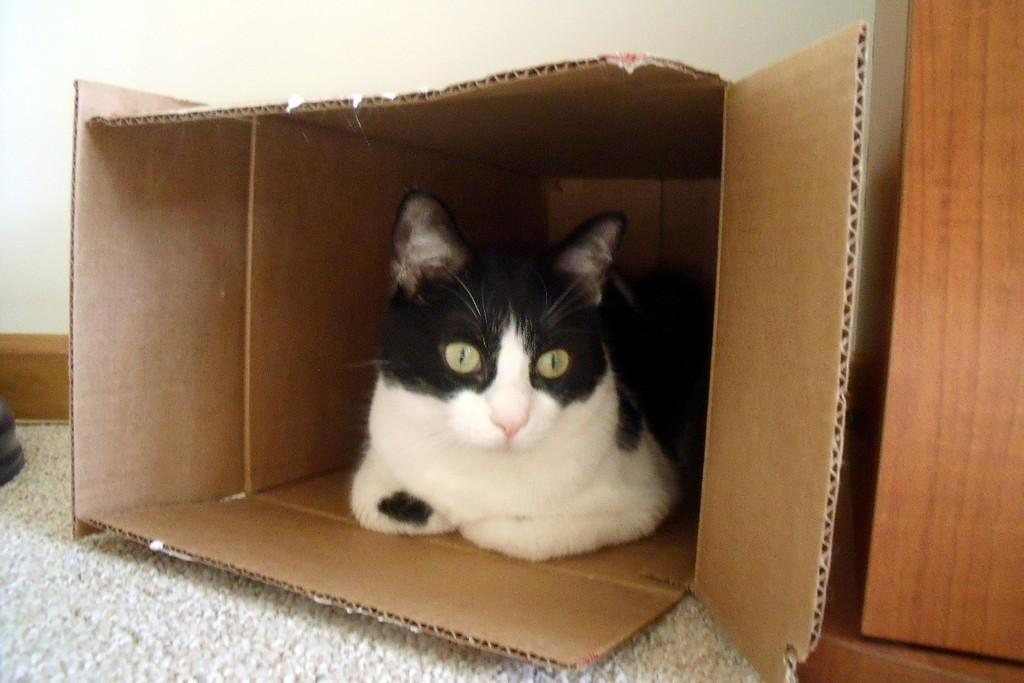What type of animal is in the image? There is a cat in the image. Where is the cat located in the image? The cat is sitting in a cardboard box. What type of tax is the cat paying in the image? There is no mention of tax in the image, and the cat is not shown engaging in any activity related to tax payment. 